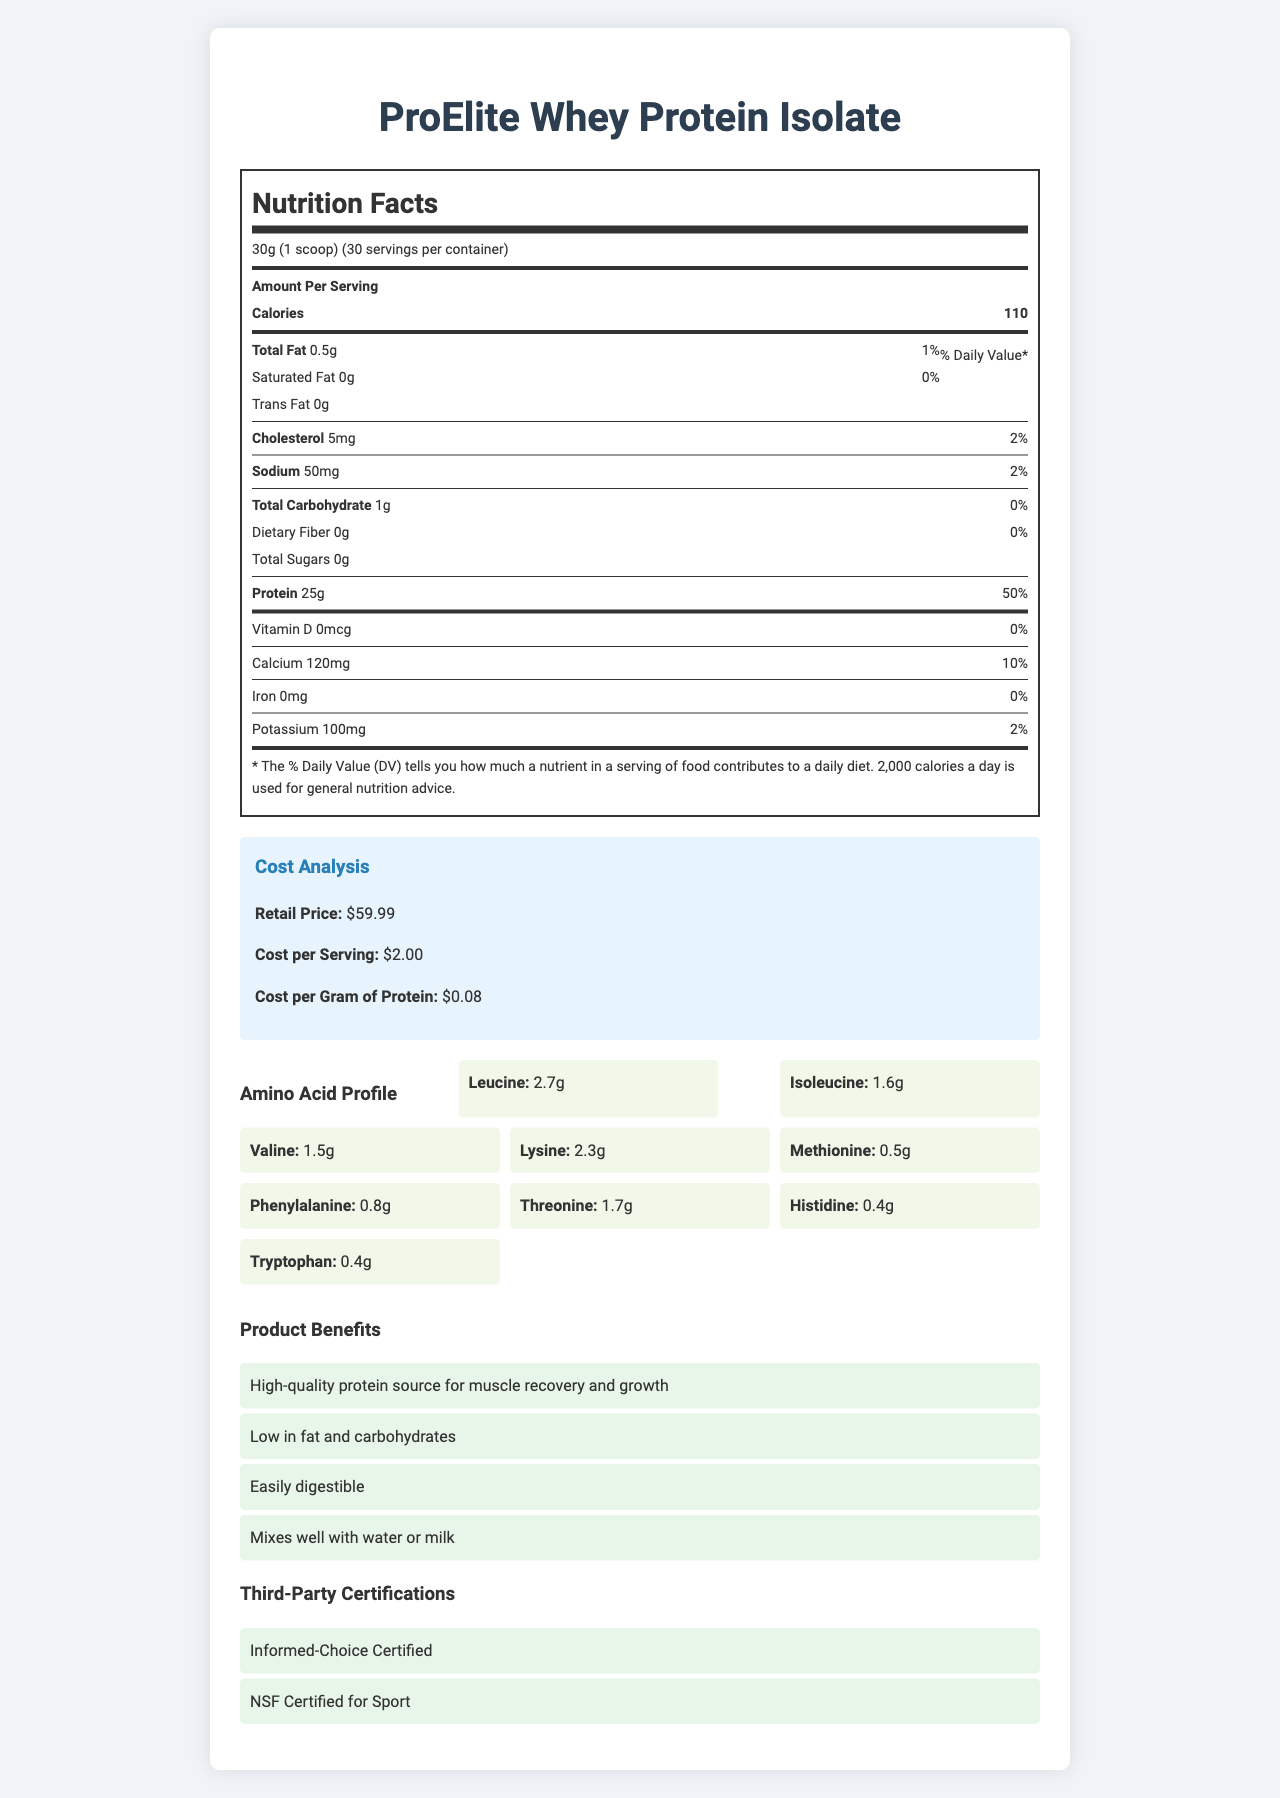what is the serving size of the ProElite Whey Protein Isolate? The document states that the serving size is 30g, which is equivalent to one scoop.
Answer: 30g (1 scoop) how many servings are in each container? The document specifies that there are 30 servings per container.
Answer: 30 how much protein is present in one serving? According to the nutrition label, one serving of the product contains 25g of protein.
Answer: 25g what is the retail price of the ProElite Whey Protein Isolate? The cost analysis section indicates that the retail price of the product is $59.99.
Answer: $59.99 how much does each serving cost? The cost analysis section shows that the cost per serving is $2.00.
Answer: $2.00 what is the cost per gram of protein? The cost analysis specifies that the cost per gram of protein is $0.08.
Answer: $0.08 what are the benefits of the ProElite Whey Protein Isolate? The document lists these benefits under the "Product Benefits" section.
Answer: High-quality protein source for muscle recovery and growth, Low in fat and carbohydrates, Easily digestible, Mixes well with water or milk what is the total carbohydrate content per serving? The nutrition label states that there is 1g of total carbohydrates per serving.
Answer: 1g are there any third-party certifications for this product? The document mentions that the product is "Informed-Choice Certified" and "NSF Certified for Sport."
Answer: Yes Multiple-choice: which amino acid has the highest content in the ProElite Whey Protein Isolate? 
    A. Leucine 
    B. Isoleucine 
    C. Lysine 
    D. Valine The amino acid profile lists leucine content as 2.7g, the highest among the amino acids specified.
Answer: A Multiple-choice: if a customer is allergic to soy, can they consume this product?
    i. Yes
    ii. No
    iii. Maybe
    iv. Only with a doctor's recommendation The allergen information section states that the product contains soy, so it is not suitable for someone with a soy allergy.
Answer: ii True/False: the ProElite Whey Protein Isolate contains artificial flavors. The ingredients list includes "Natural and Artificial Flavors."
Answer: True Summary: describe the main idea of the document. The document provides a comprehensive overview of the ProElite Whey Protein Isolate, focusing on nutritional information, cost analysis, product benefits, and other relevant details to help consumers make an informed decision.
Answer: The document outlines the nutrition facts, cost analysis, and product benefits of the ProElite Whey Protein Isolate. It provides detailed information on serving size, calories, fat content, protein content, and other nutrients. The cost analysis includes retail price, cost per serving, and cost per gram of protein. Additionally, the document highlights the amino acid profile, product benefits, third-party certifications, manufacturing details, sustainability info, and customer support contact. what is the expiration date of this product? The manufacturing details section lists the expiration date as 05/01/2025.
Answer: 05/01/2025 how many grams of leucine are in one serving? The amino acid profile section indicates that one serving contains 2.7g of leucine.
Answer: 2.7g what is the primary source of protein in this product? The ingredients list confirms that the primary source of protein is whey protein isolate.
Answer: Whey Protein Isolate what type of certifications does the ProElite Whey Protein Isolate have? The document lists these certifications under the "Third-Party Certifications" section.
Answer: Informed-Choice Certified, NSF Certified for Sport what is the sodium content for each serving? The nutrition label specifies that each serving contains 50mg of sodium.
Answer: 50mg which company manufactures the ProElite Whey Protein Isolate? The manufacturing details section states that NutriFit Labs, Inc., manufactures the product.
Answer: NutriFit Labs, Inc. how much calcium is present per serving? The nutrition label indicates that each serving contains 120mg of calcium.
Answer: 120mg where is the manufacturing location for this product? The manufacturing details section lists the location as San Diego, CA, USA.
Answer: San Diego, CA, USA Unanswerable: what is the exact production date of this batch? The document provides the lot number and expiration date but does not include the production date.
Answer: Not enough information 